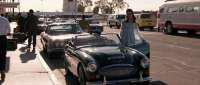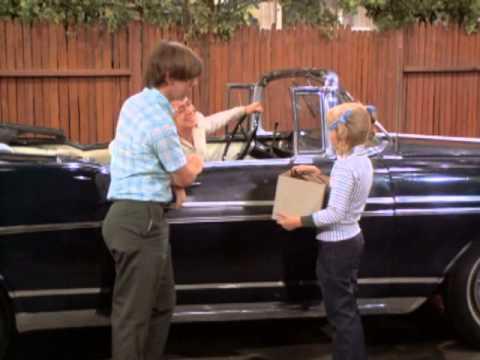The first image is the image on the left, the second image is the image on the right. Examine the images to the left and right. Is the description "in the left image there is a sidewalk to the left of the car" accurate? Answer yes or no. Yes. The first image is the image on the left, the second image is the image on the right. Analyze the images presented: Is the assertion "Contains a car that is facing to the left side." valid? Answer yes or no. No. 